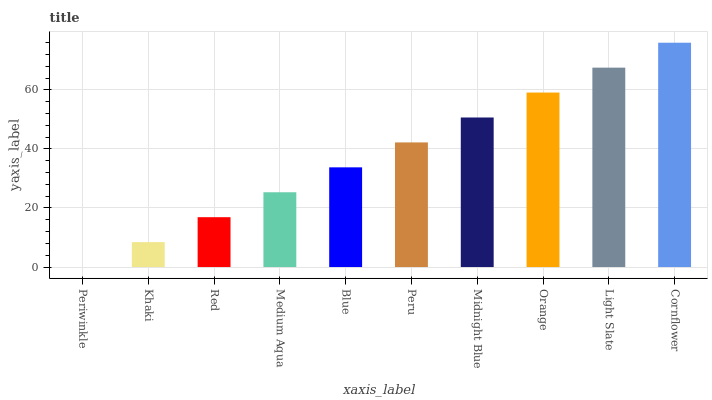Is Periwinkle the minimum?
Answer yes or no. Yes. Is Cornflower the maximum?
Answer yes or no. Yes. Is Khaki the minimum?
Answer yes or no. No. Is Khaki the maximum?
Answer yes or no. No. Is Khaki greater than Periwinkle?
Answer yes or no. Yes. Is Periwinkle less than Khaki?
Answer yes or no. Yes. Is Periwinkle greater than Khaki?
Answer yes or no. No. Is Khaki less than Periwinkle?
Answer yes or no. No. Is Peru the high median?
Answer yes or no. Yes. Is Blue the low median?
Answer yes or no. Yes. Is Red the high median?
Answer yes or no. No. Is Cornflower the low median?
Answer yes or no. No. 